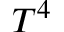<formula> <loc_0><loc_0><loc_500><loc_500>T ^ { 4 }</formula> 